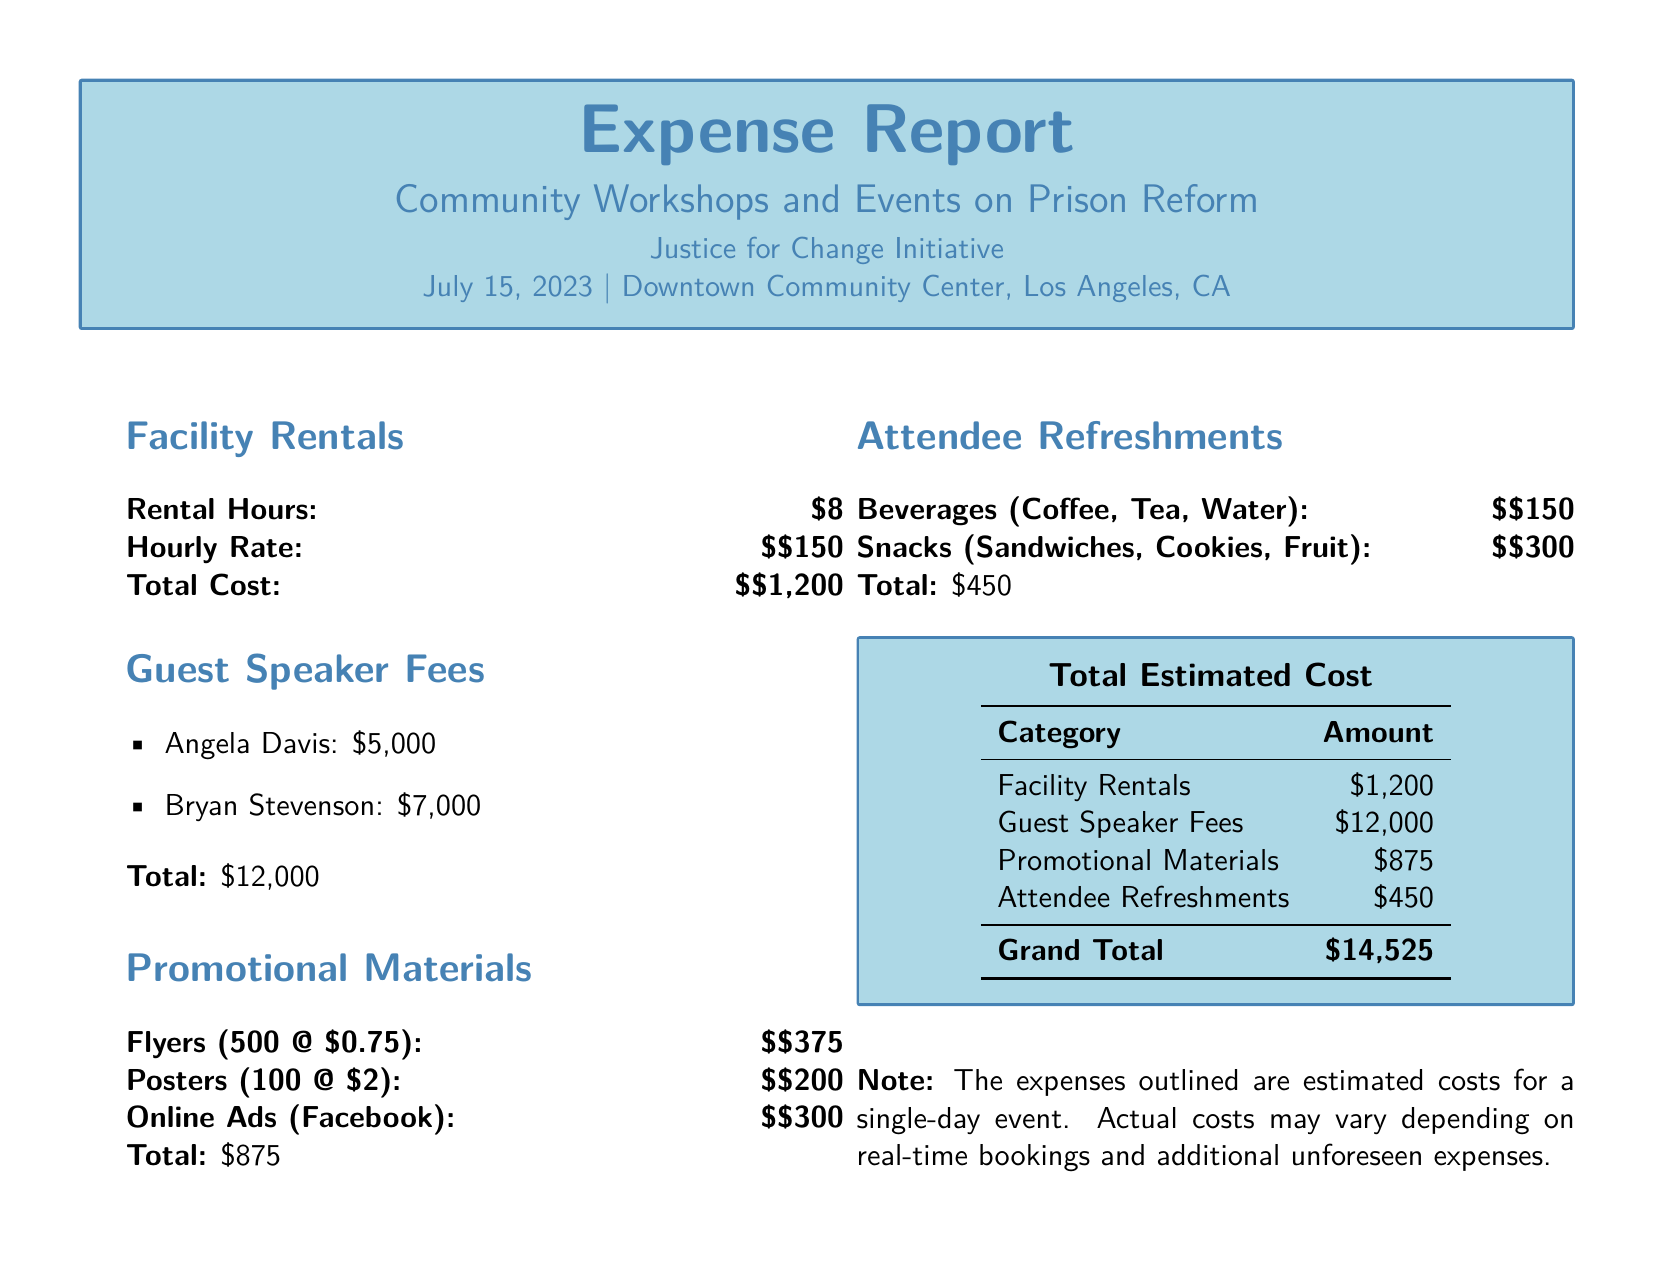What is the total cost for facility rentals? The total cost for facility rentals is clearly stated in the document under Facility Rentals, which is $1,200.
Answer: $1,200 Who are the guest speakers featured in the report? The report lists guest speakers under Guest Speaker Fees, including Angela Davis and Bryan Stevenson.
Answer: Angela Davis, Bryan Stevenson What is the total amount spent on promotional materials? The total amount for promotional materials is calculated and presented at the end of the respective section, which amounts to $875.
Answer: $875 How much was spent on attendee refreshments? The section for Attendee Refreshments specifies the total spent on refreshments, which is $450.
Answer: $450 What is the grand total of all expenses? The grand total is derived by summing all categories of expenses, which totals $14,525.
Answer: $14,525 How many hours was the facility rented for? The report states the facility was rented for 8 hours under Facility Rentals.
Answer: 8 What is the hourly rate for facility rentals? The hourly rate is explicitly mentioned in the report, which is $150.
Answer: $150 Which type of promotional materials was budgeted for online ads? The report includes Online Ads under Promotional Materials, specifying a budget for this category.
Answer: Online Ads What type of refreshments were provided to attendees? The report lists beverages and snacks, denoting the types of refreshments provided.
Answer: Beverages, Snacks 